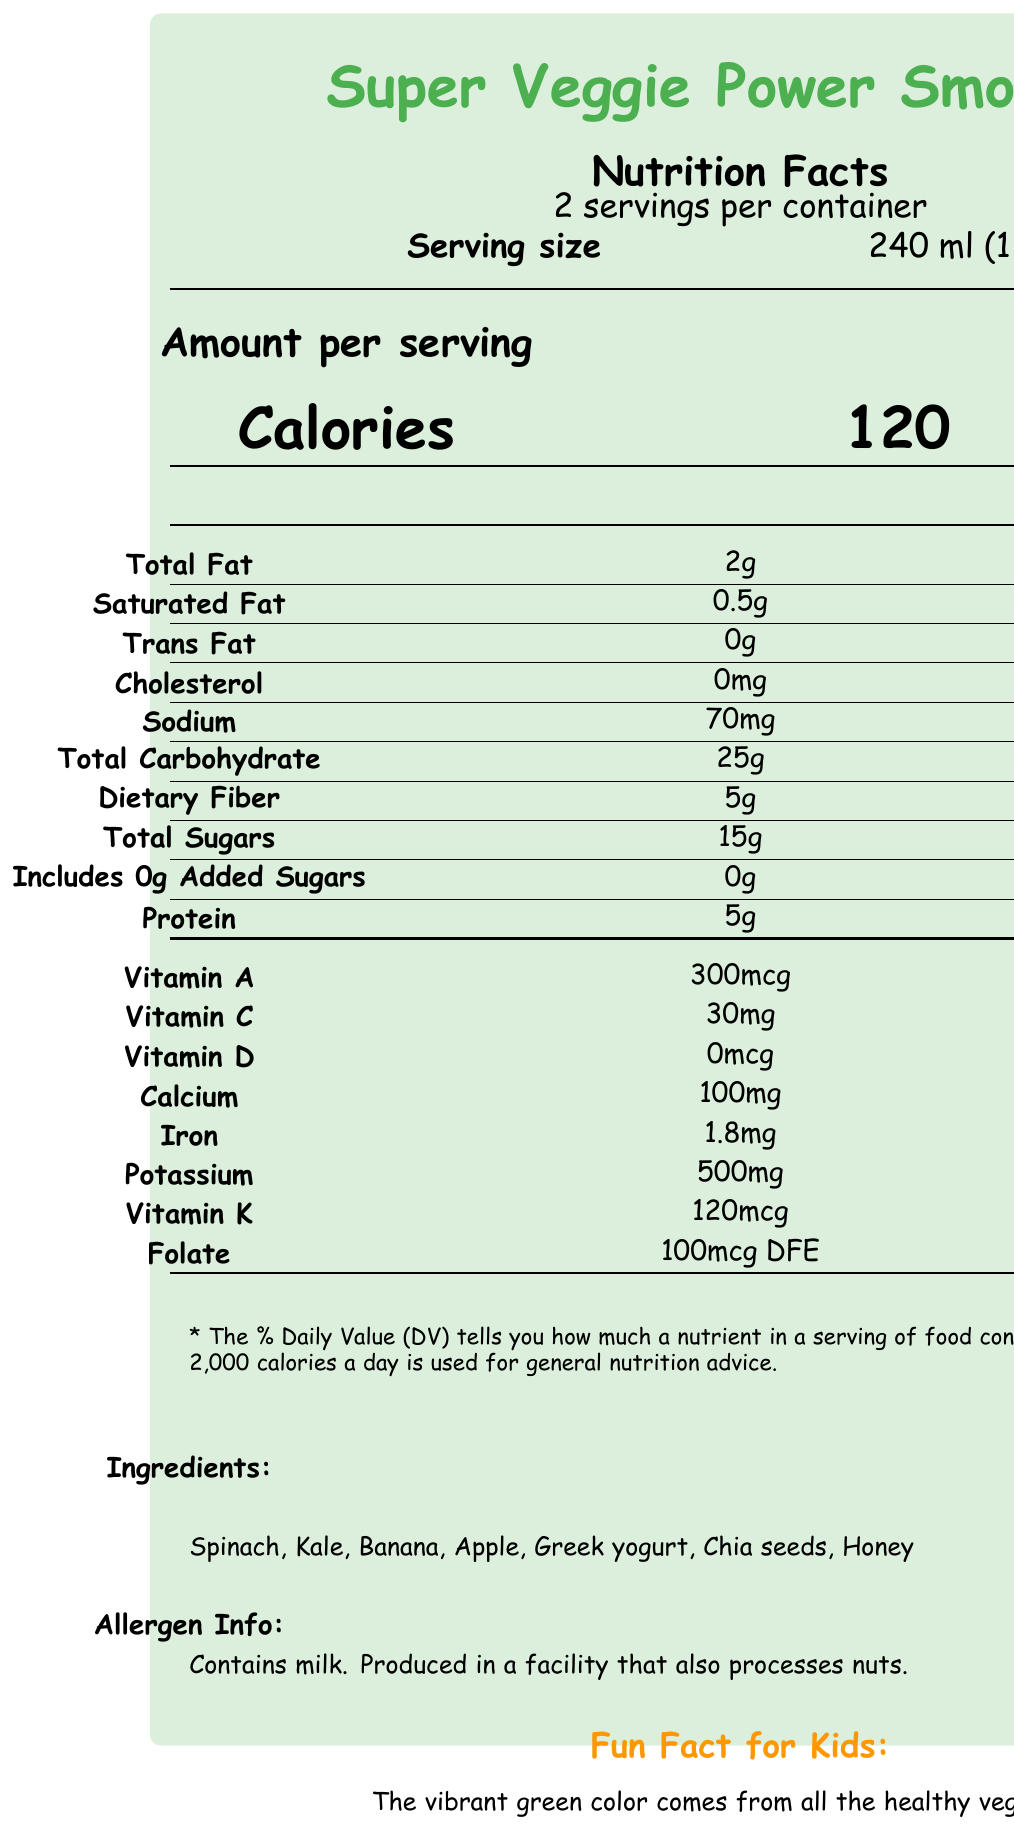What is the serving size for the Super Veggie Power Smoothie? The document specifies the serving size directly under the "Nutrition Facts" header.
Answer: 240 ml (1 cup) How many servings are in one container of the smoothie? The document mentions “2 servings per container” right under the “Nutrition Facts” header.
Answer: 2 servings What amount of Vitamin A is in a single serving of the smoothie? The document lists the amount of Vitamin A under the nutrient breakdown section.
Answer: 300mcg What percentage of the Daily Value (DV) of Vitamin K does one serving of the smoothie provide? The document states that one serving provides 100% of the Daily Value for Vitamin K.
Answer: 100% What are the main ingredients in this smoothie? The document lists these ingredients under the "Ingredients" section towards the bottom.
Answer: Spinach, Kale, Banana, Apple, Greek yogurt, Chia seeds, Honey Is this smoothie a good source of dietary fiber? The dietary fiber content is 5g per serving, which is 18% of the Daily Value, indicating it is a good source of fiber.
Answer: Yes How many calories are in one serving of the smoothie? The calories content per serving is clearly listed in bold under the "Amount per serving" section.
Answer: 120 calories Which mineral can be found in the amount of 500mg per serving in the smoothie?
A. Calcium  
B. Iron  
C. Potassium  
D. Sodium The document lists Potassium as having 500mg per serving.
Answer: C. Potassium What is the percentage of the Daily Value of Iron provided by a single serving of the smoothie?
I. 8%  
II. 10%  
III. 18%  
IV. 25% The document specifies that one serving covers 10% of the Daily Value for Iron.
Answer: II. 10% Is this smoothie free from added sugars? The document shows "Includes 0g Added Sugars" with a 0% Daily Value, indicating it is free from added sugars.
Answer: Yes Summarize the main idea of the document. The summary outlines the key sections and nutritional benefits described in the document, emphasizing its value for children.
Answer: The document provides comprehensive nutrition information for the "Super Veggie Power Smoothie," highlighting its serving size, calories, and nutrient content, including vitamins and minerals. It also mentions the ingredients, allergen information, fun facts for kids, and some ideas for experimentation. The smoothie is promoted as being rich in essential nutrients like vitamins A, C, K, fiber, iron, and calcium, making it beneficial for kids. What kind of experiments can you perform with this smoothie? The document lists these ideas under the "experiment ideas" section.
Answer: Try adding different fruits to change the color and taste, freeze the smoothie into popsicle molds for a cool treat, and use it as a base for homemade fruit and veggie gummies. What is the allergen information for this smoothie? The allergen information is clearly labeled under the "Allergen Info" section.
Answer: Contains milk. Produced in a facility that also processes nuts. What ingredient is responsible for the calcium content in the smoothie? The document's parent-friendly notes mention that calcium comes from Greek yogurt.
Answer: Greek yogurt Can this document tell you the price of the smoothie? The document does not provide any information about the price of the smoothie.
Answer: Cannot be determined 